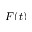Convert formula to latex. <formula><loc_0><loc_0><loc_500><loc_500>F ( t )</formula> 